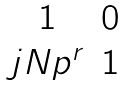<formula> <loc_0><loc_0><loc_500><loc_500>\begin{matrix} 1 & 0 \\ j N p ^ { r } & 1 \end{matrix}</formula> 